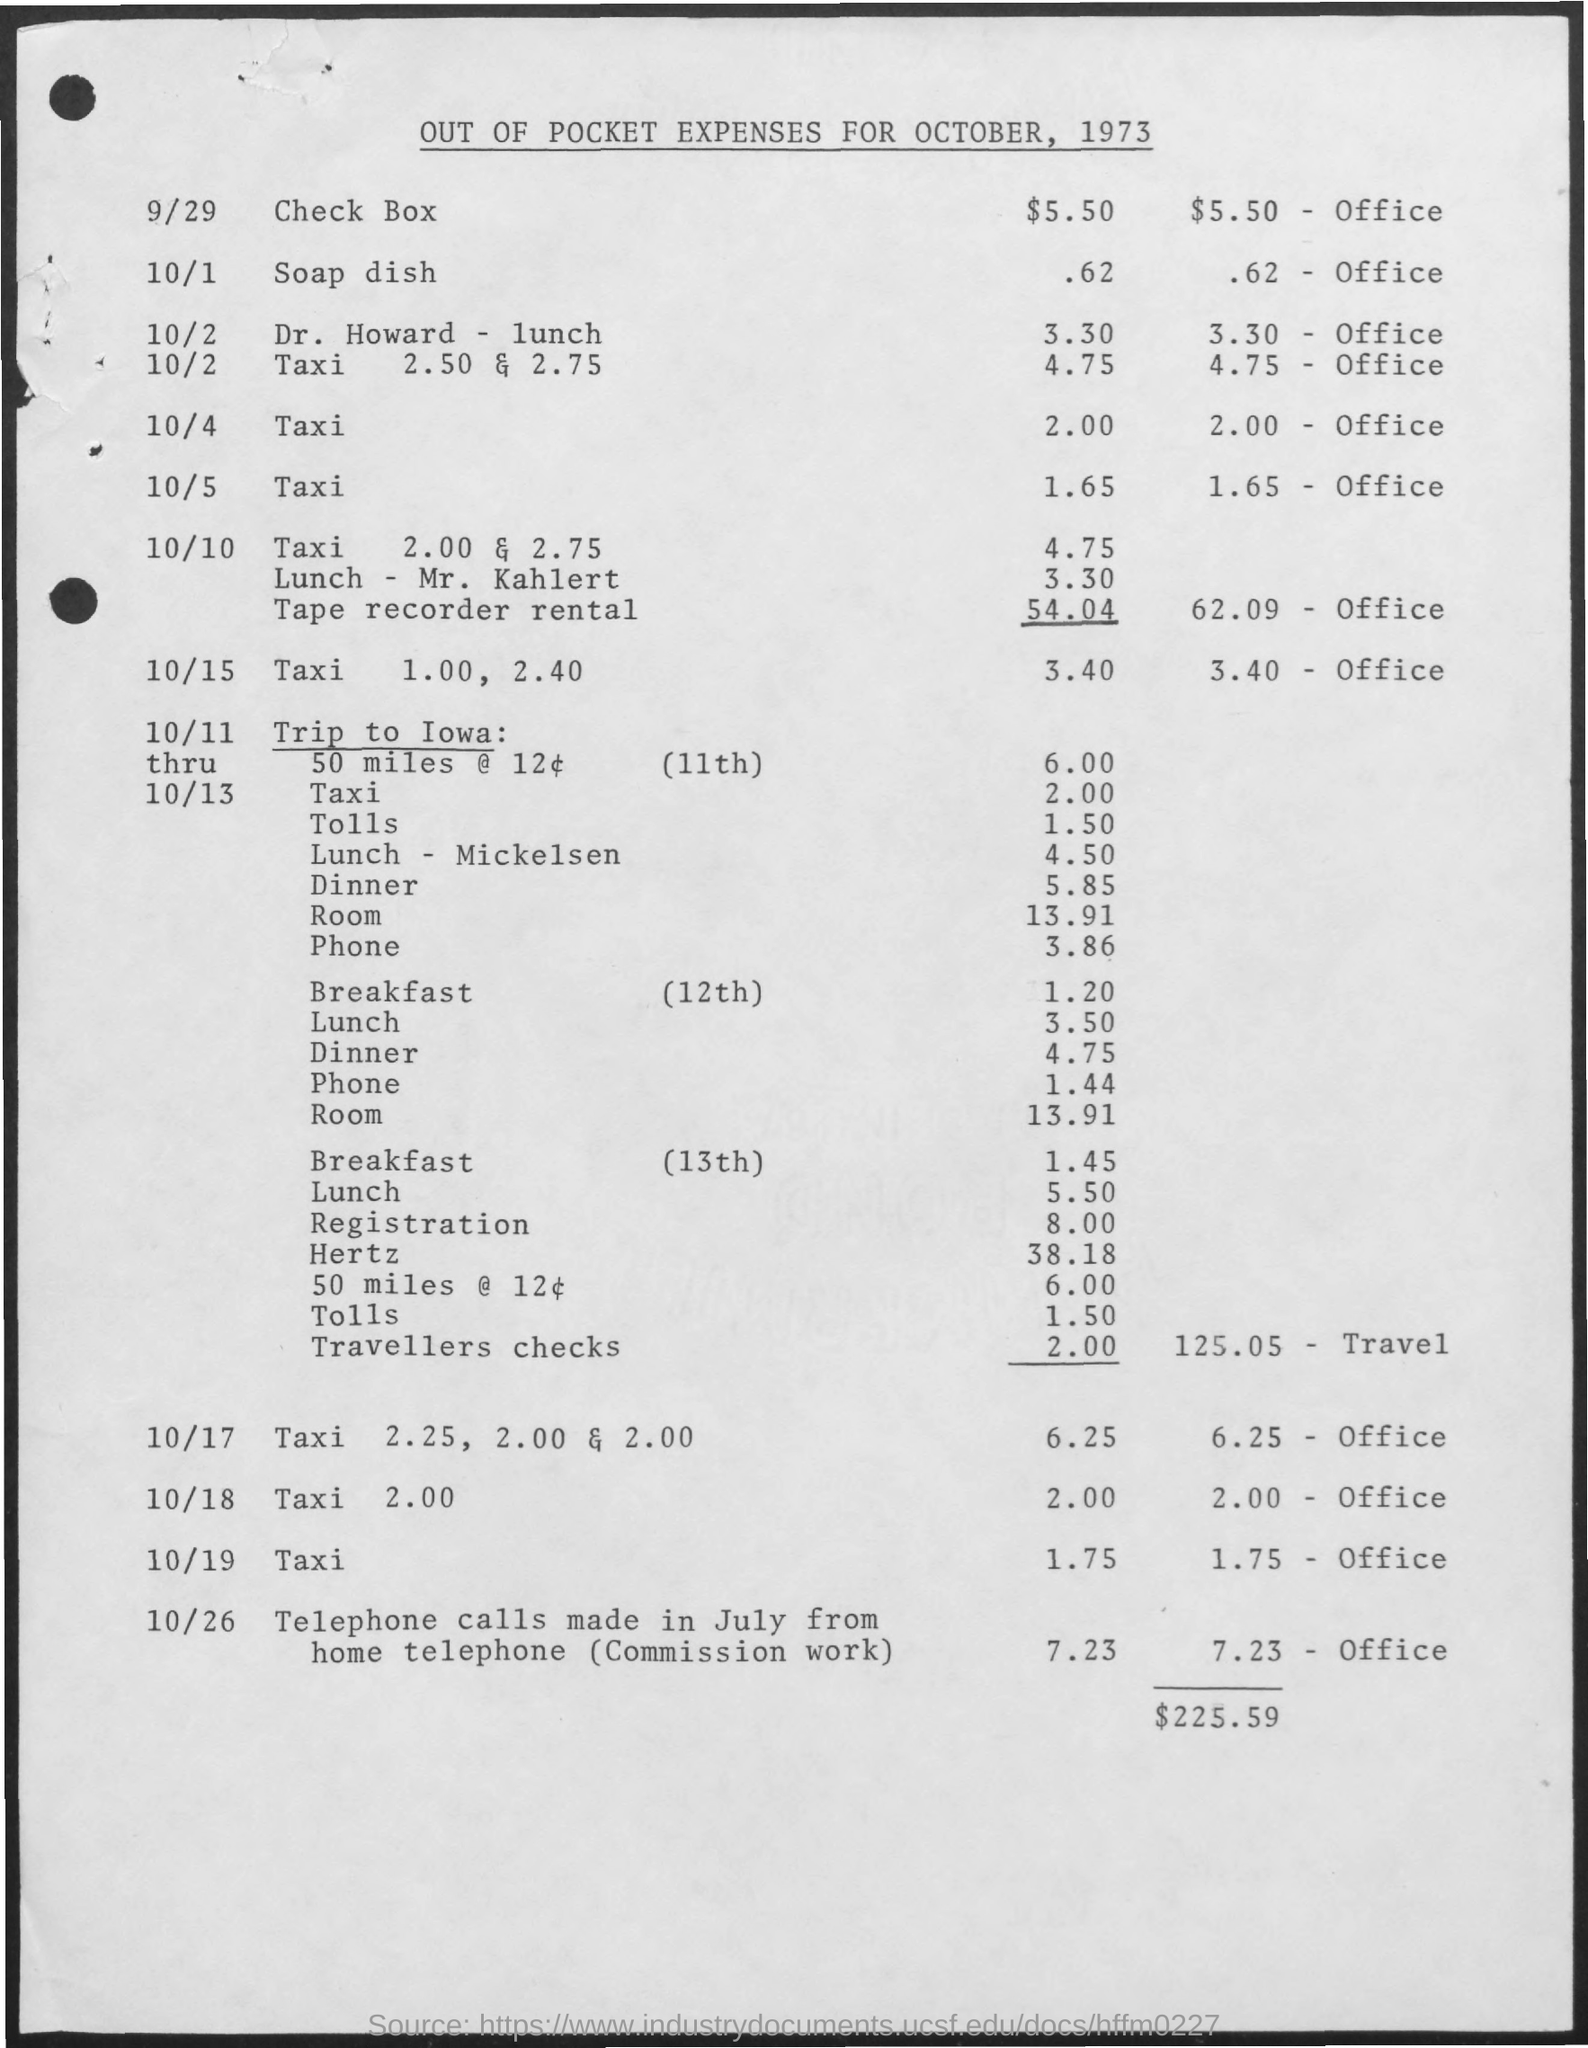Identify some key points in this picture. The out-of-pocket expenses were calculated for the month and year of October, 1973. The cost of a check box is $5.50. The total amount spent is 225.59. On October 19th, the amount spent on taxi was 1.75. 